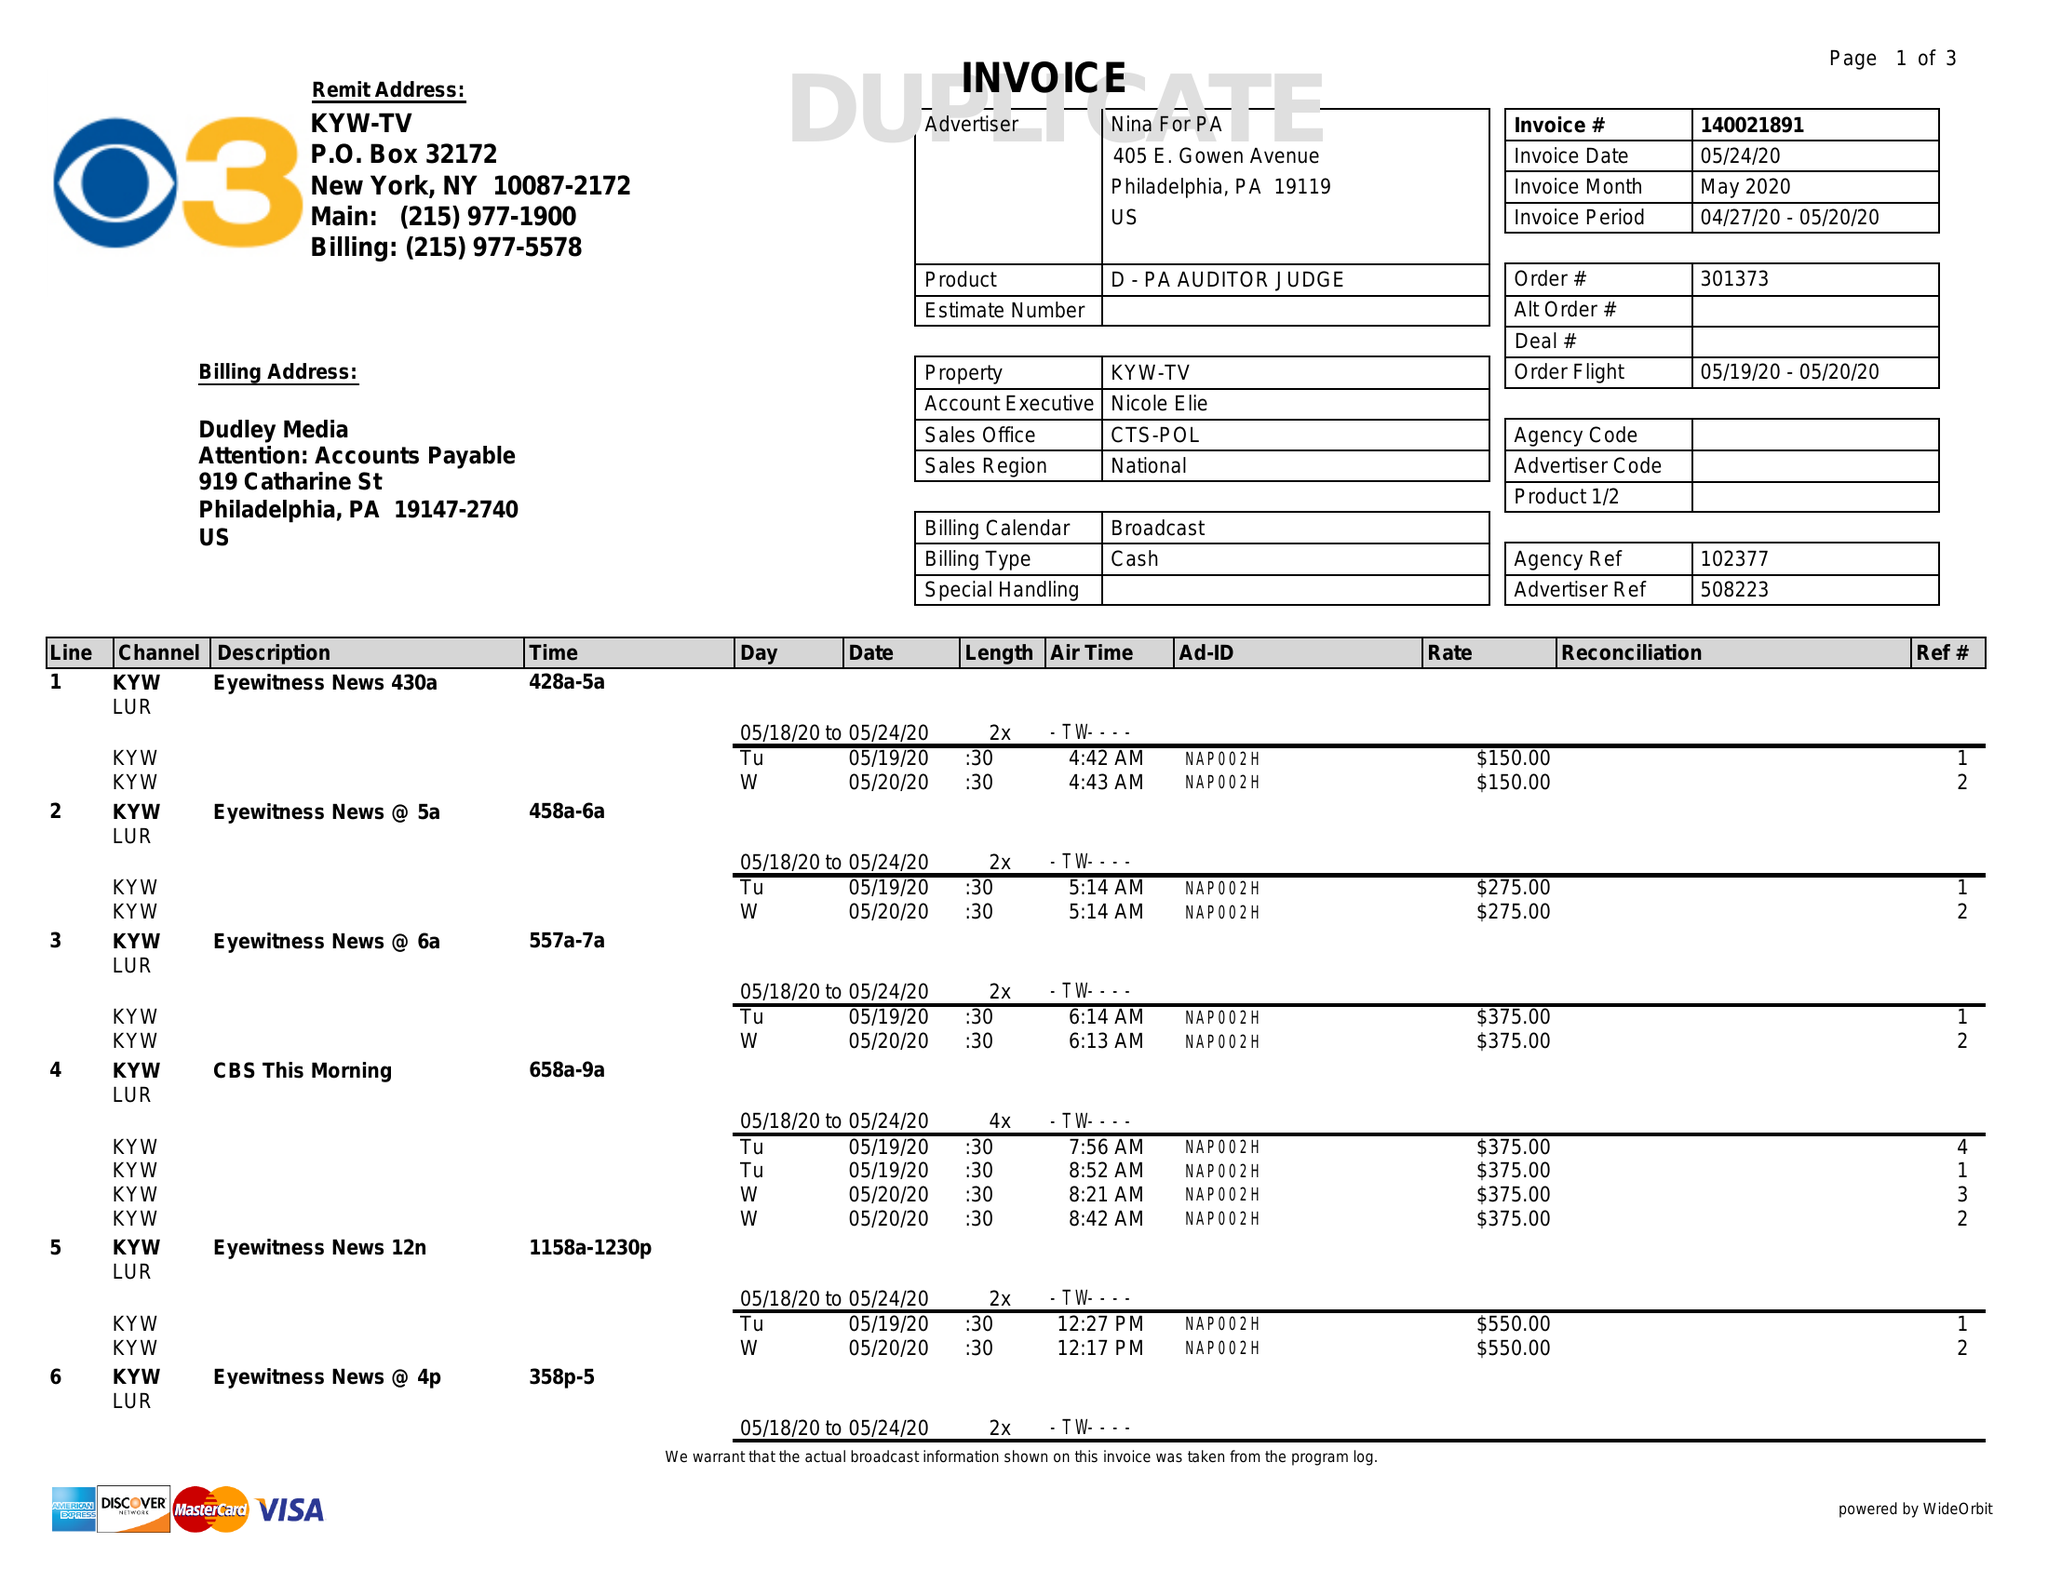What is the value for the flight_to?
Answer the question using a single word or phrase. 05/20/20 